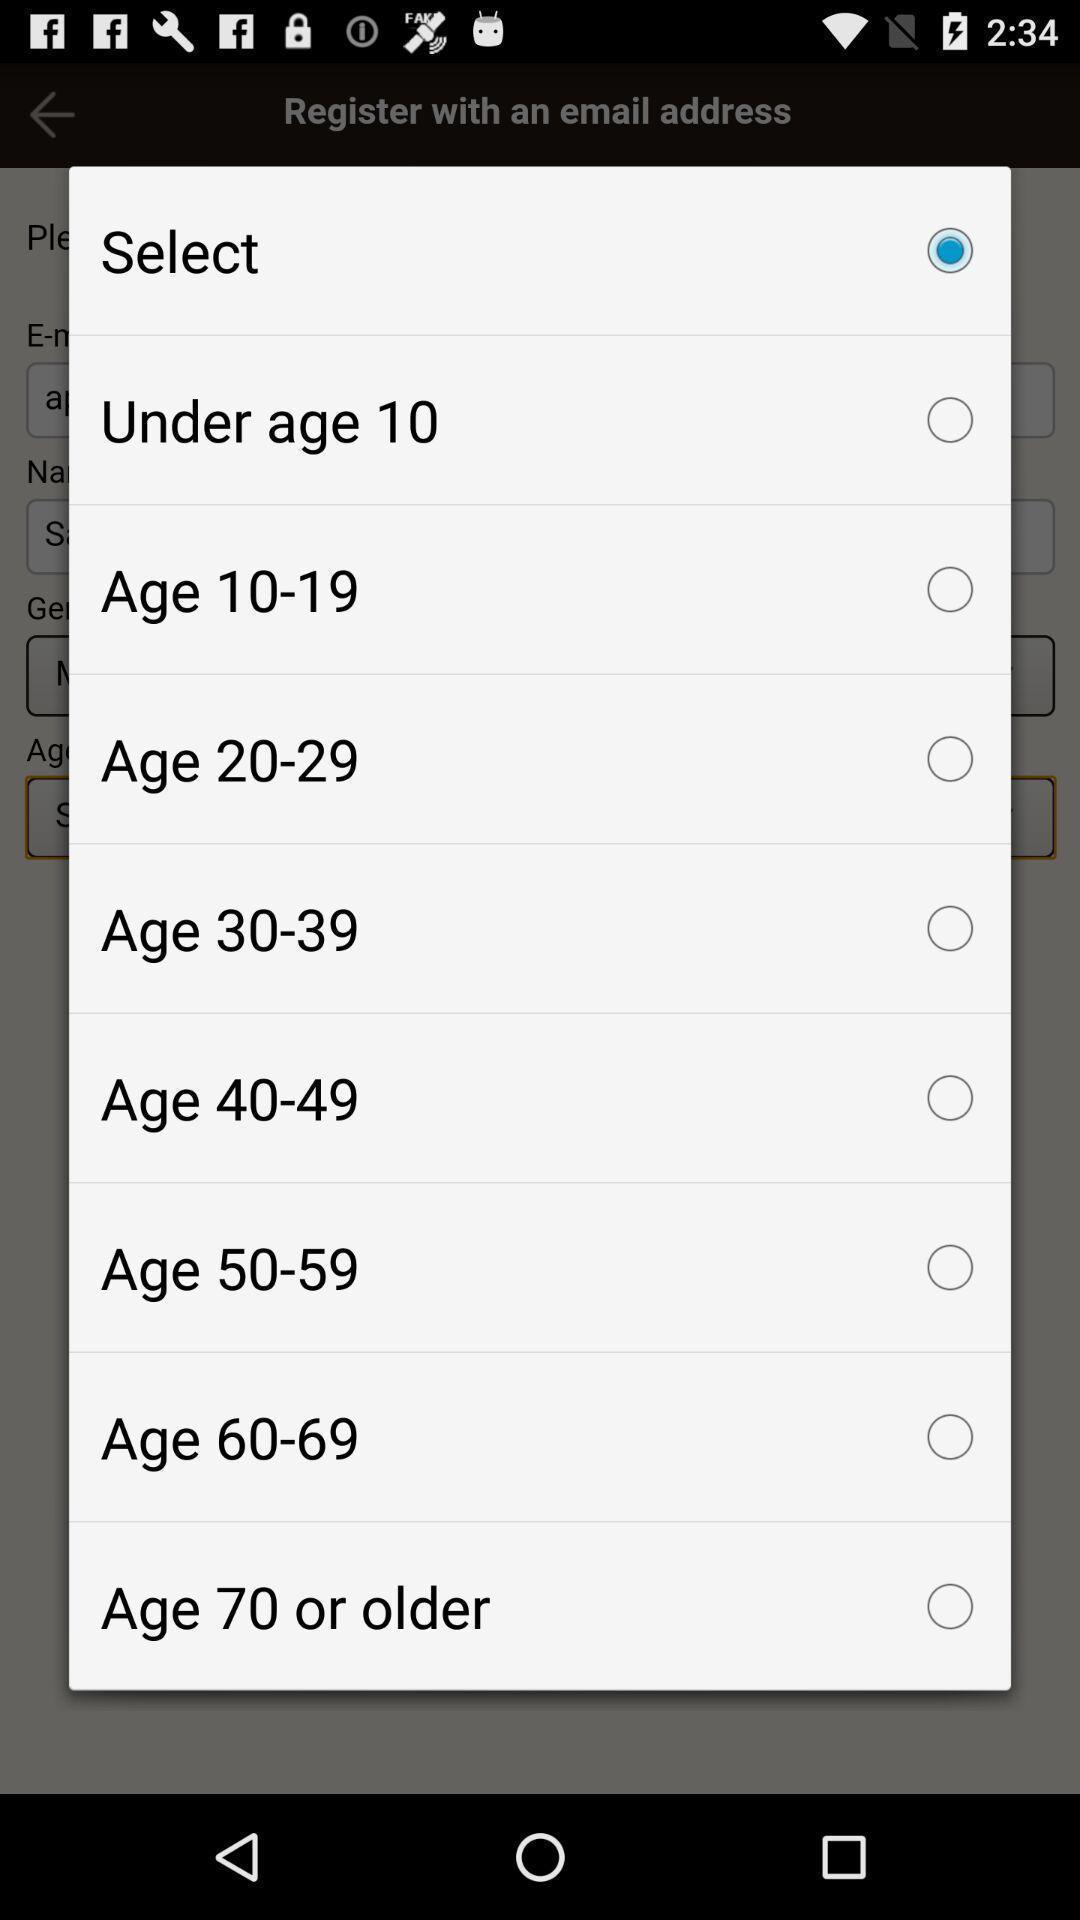What can you discern from this picture? Popup of series of age periods to select. 